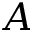<formula> <loc_0><loc_0><loc_500><loc_500>A</formula> 